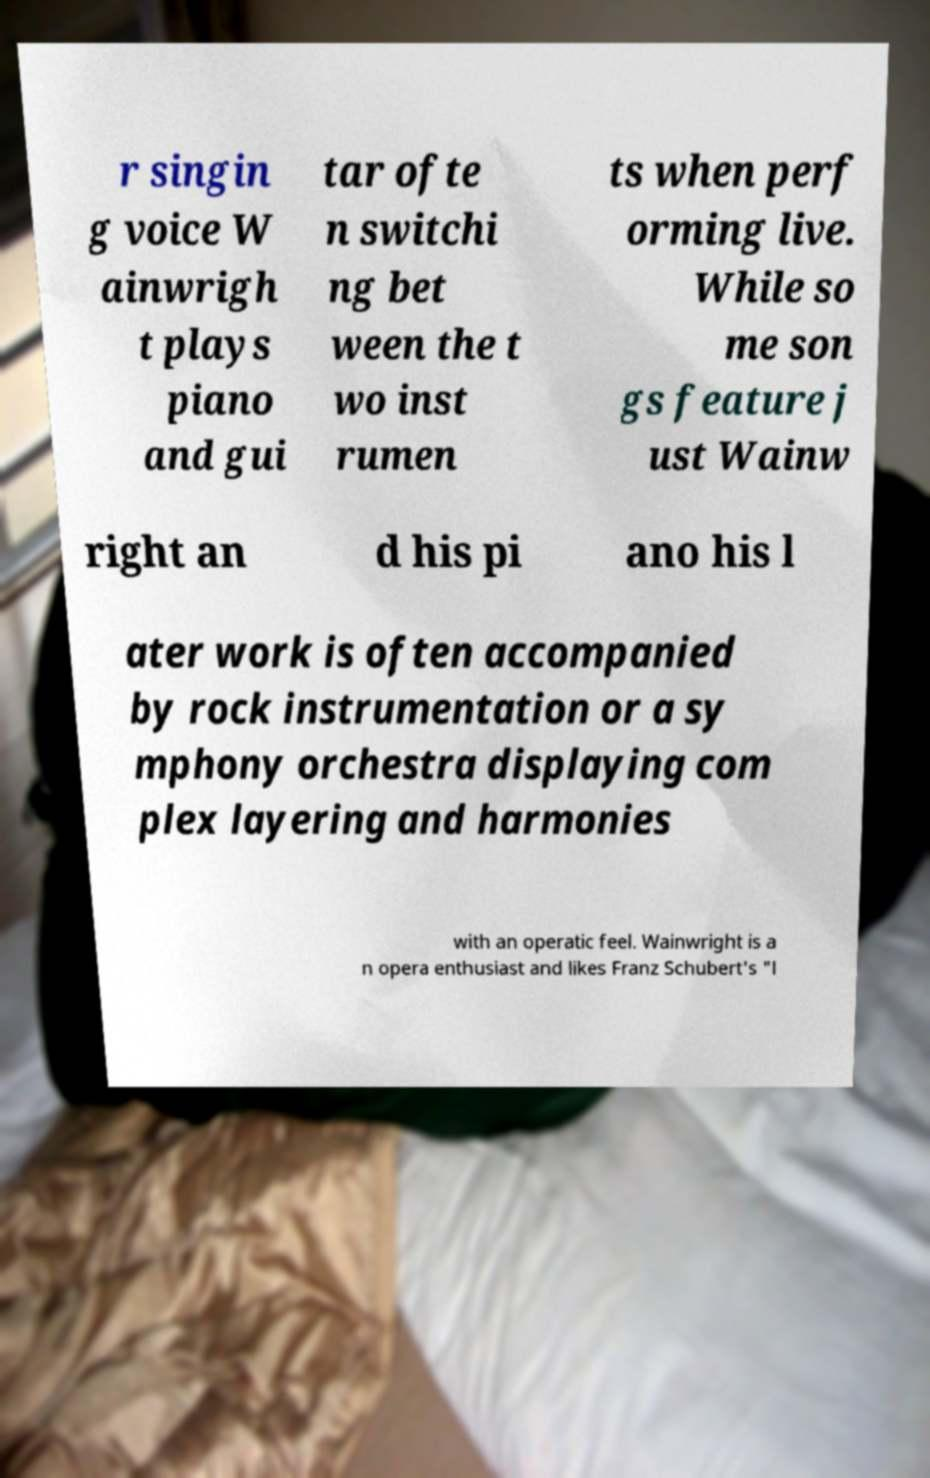For documentation purposes, I need the text within this image transcribed. Could you provide that? r singin g voice W ainwrigh t plays piano and gui tar ofte n switchi ng bet ween the t wo inst rumen ts when perf orming live. While so me son gs feature j ust Wainw right an d his pi ano his l ater work is often accompanied by rock instrumentation or a sy mphony orchestra displaying com plex layering and harmonies with an operatic feel. Wainwright is a n opera enthusiast and likes Franz Schubert's "l 